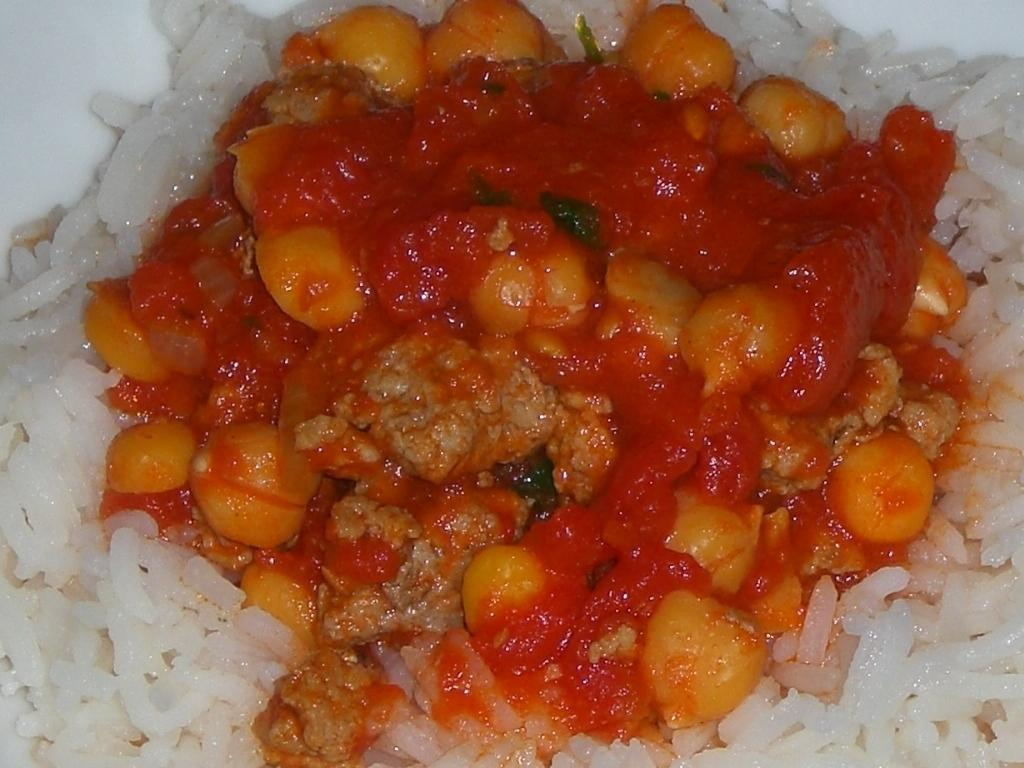What type of food is visible in the image? The image contains rice and curry. Can you describe the curry in the image? The curry is red in color. What type of pain is being experienced by the person in the image? There is no person present in the image, and therefore no indication of any pain being experienced. What type of iron object is visible in the image? There is no iron object present in the image. 